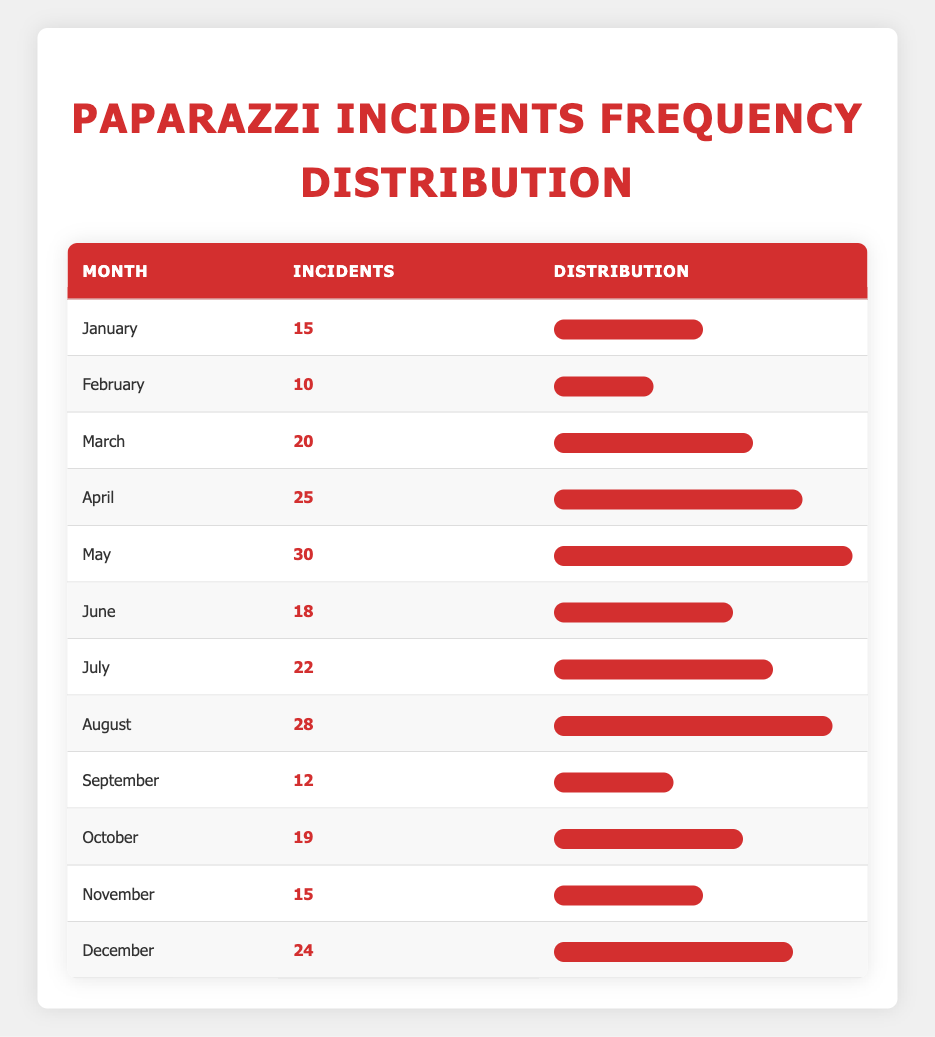What is the month with the highest number of paparazzi incidents? To find the highest number of incidents, we can scan through the table to compare the values. May has the highest recorded incidents at 30.
Answer: May How many incidents occurred in September? By simply looking at the table, the number of incidents listed for September is 12.
Answer: 12 What is the total number of incidents for the first half of the year (January to June)? We need to add the number of incidents from January to June: 15 (Jan) + 10 (Feb) + 20 (Mar) + 25 (Apr) + 30 (May) + 18 (Jun) = 118.
Answer: 118 Is there any month where the number of incidents was greater than 25? By reviewing the data in the table, we can see April (25), May (30), August (28), and December (24) had incidents greater than 25. Thus, the answer is yes.
Answer: Yes What is the average number of incidents across all months? To calculate the average, first sum all the incidents: 15 + 10 + 20 + 25 + 30 + 18 + 22 + 28 + 12 + 19 + 15 + 24 =  24.5. Then divide by the number of months (12):  24.5.
Answer: 24.5 Which month had the least number of incidents? By looking at the recorded incidents, February shows the least number of incidents with a count of 10.
Answer: February If we compare July and June, which month had more incidents, and by how many? By checking the table, July had 22 incidents, while June had 18 incidents. Thus, July had 4 incidents more than June.
Answer: July by 4 What percentage of incidents in August are compared to the total incidents for the year? Total incidents for the year are 285. August had 28 incidents; so the percentage is (28/285) * 100 = 9.82%.
Answer: 9.82% 